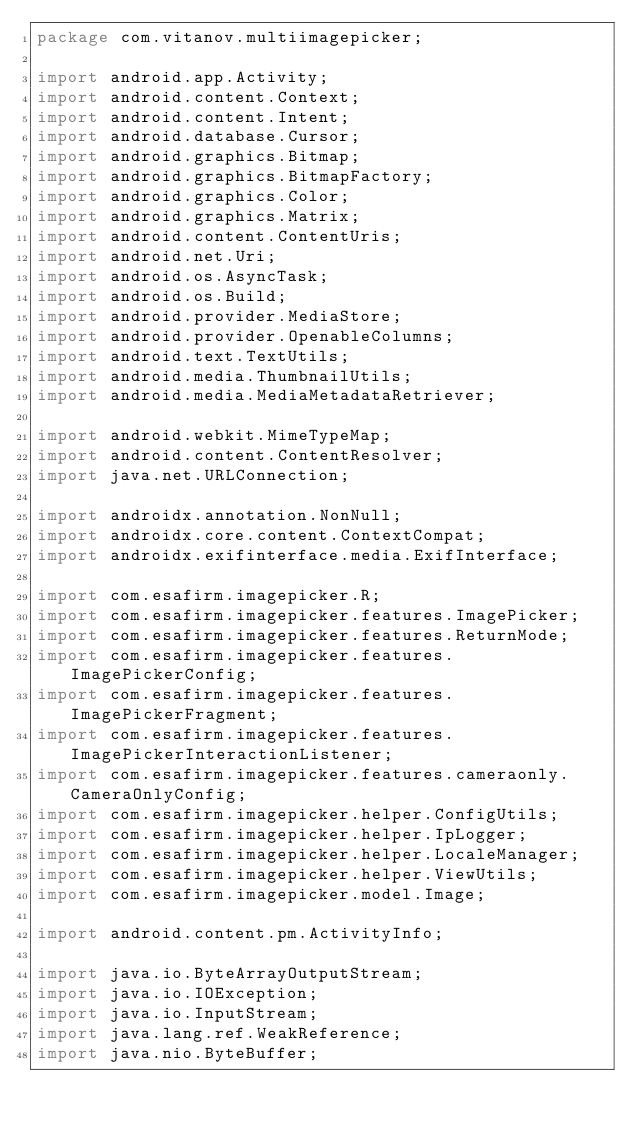<code> <loc_0><loc_0><loc_500><loc_500><_Java_>package com.vitanov.multiimagepicker;

import android.app.Activity;
import android.content.Context;
import android.content.Intent;
import android.database.Cursor;
import android.graphics.Bitmap;
import android.graphics.BitmapFactory;
import android.graphics.Color;
import android.graphics.Matrix;
import android.content.ContentUris;
import android.net.Uri;
import android.os.AsyncTask;
import android.os.Build;
import android.provider.MediaStore;
import android.provider.OpenableColumns;
import android.text.TextUtils;
import android.media.ThumbnailUtils;
import android.media.MediaMetadataRetriever;

import android.webkit.MimeTypeMap;
import android.content.ContentResolver;
import java.net.URLConnection;

import androidx.annotation.NonNull;
import androidx.core.content.ContextCompat;
import androidx.exifinterface.media.ExifInterface;

import com.esafirm.imagepicker.R;
import com.esafirm.imagepicker.features.ImagePicker;
import com.esafirm.imagepicker.features.ReturnMode;
import com.esafirm.imagepicker.features.ImagePickerConfig;
import com.esafirm.imagepicker.features.ImagePickerFragment;
import com.esafirm.imagepicker.features.ImagePickerInteractionListener;
import com.esafirm.imagepicker.features.cameraonly.CameraOnlyConfig;
import com.esafirm.imagepicker.helper.ConfigUtils;
import com.esafirm.imagepicker.helper.IpLogger;
import com.esafirm.imagepicker.helper.LocaleManager;
import com.esafirm.imagepicker.helper.ViewUtils;
import com.esafirm.imagepicker.model.Image;

import android.content.pm.ActivityInfo;

import java.io.ByteArrayOutputStream;
import java.io.IOException;
import java.io.InputStream;
import java.lang.ref.WeakReference;
import java.nio.ByteBuffer;</code> 